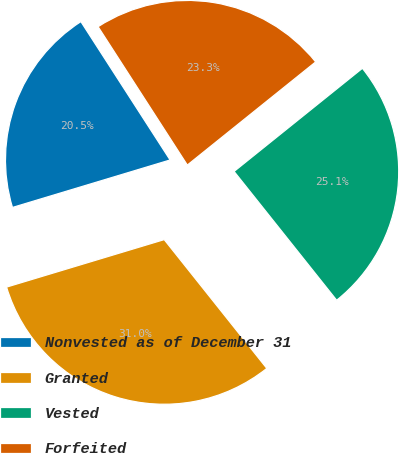<chart> <loc_0><loc_0><loc_500><loc_500><pie_chart><fcel>Nonvested as of December 31<fcel>Granted<fcel>Vested<fcel>Forfeited<nl><fcel>20.54%<fcel>31.05%<fcel>25.07%<fcel>23.34%<nl></chart> 